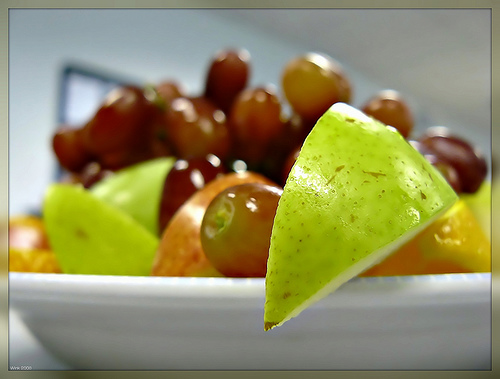<image>
Is the apple slice on the grape? Yes. Looking at the image, I can see the apple slice is positioned on top of the grape, with the grape providing support. 